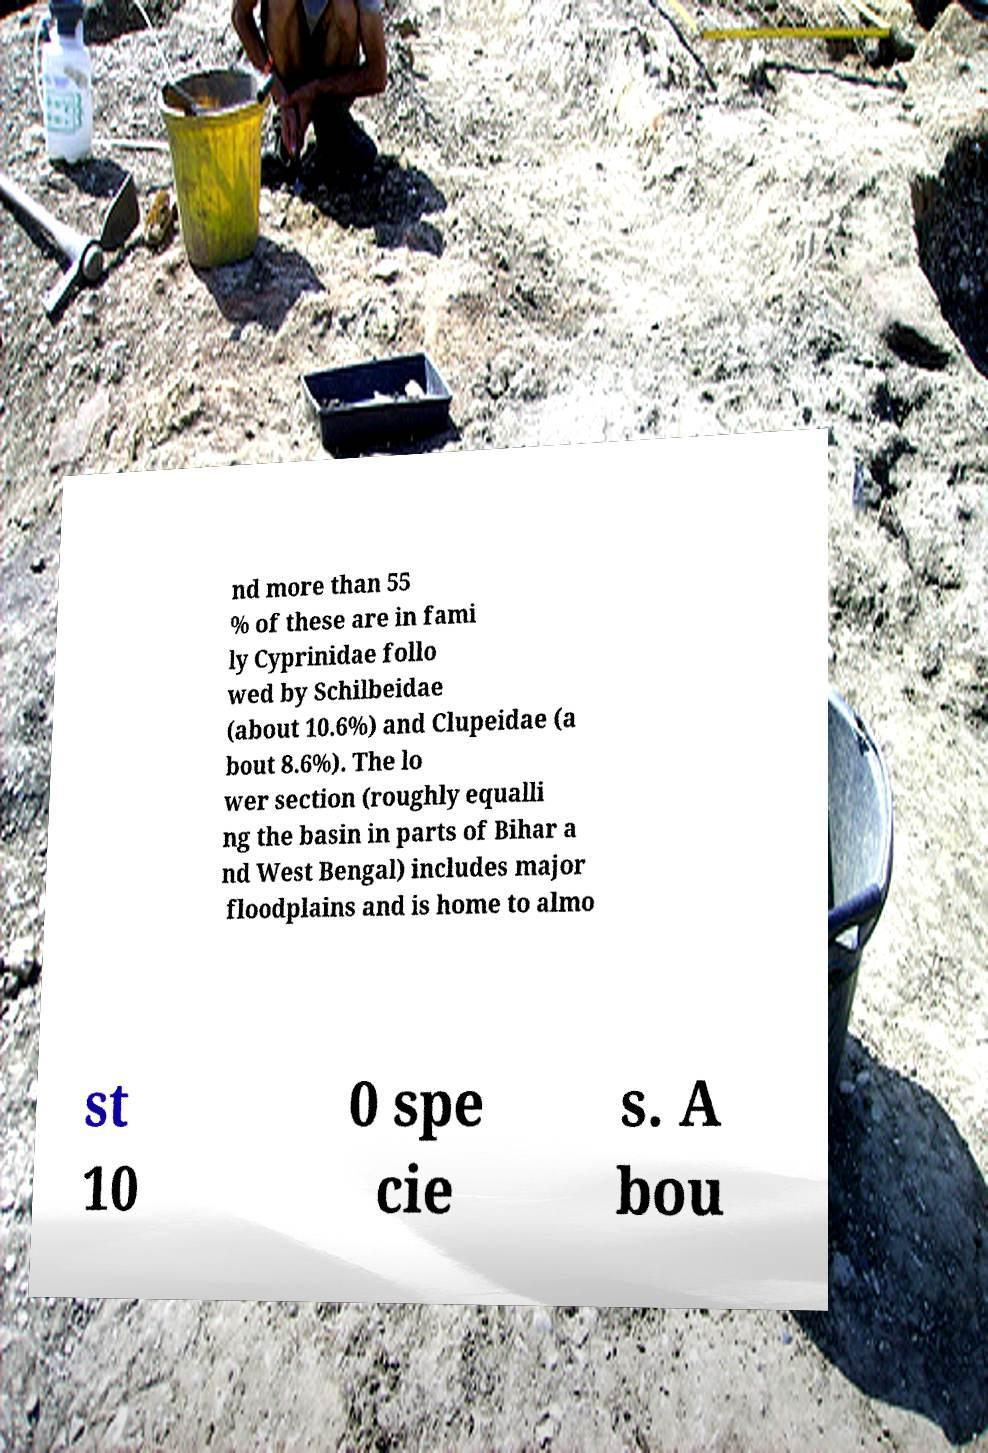Can you read and provide the text displayed in the image?This photo seems to have some interesting text. Can you extract and type it out for me? nd more than 55 % of these are in fami ly Cyprinidae follo wed by Schilbeidae (about 10.6%) and Clupeidae (a bout 8.6%). The lo wer section (roughly equalli ng the basin in parts of Bihar a nd West Bengal) includes major floodplains and is home to almo st 10 0 spe cie s. A bou 